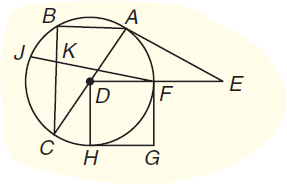Question: A E is a tangent. If A D = 12 and F E = 18, how long is A E to the nearest tenth unit?
Choices:
A. 27.5
B. 55
C. 60
D. 90
Answer with the letter. Answer: A Question: Chords J F and B C intersect at K. If B K = 8, K C = 12, and K F = 16, find J K.
Choices:
A. 6
B. 12
C. 15
D. 18
Answer with the letter. Answer: A 